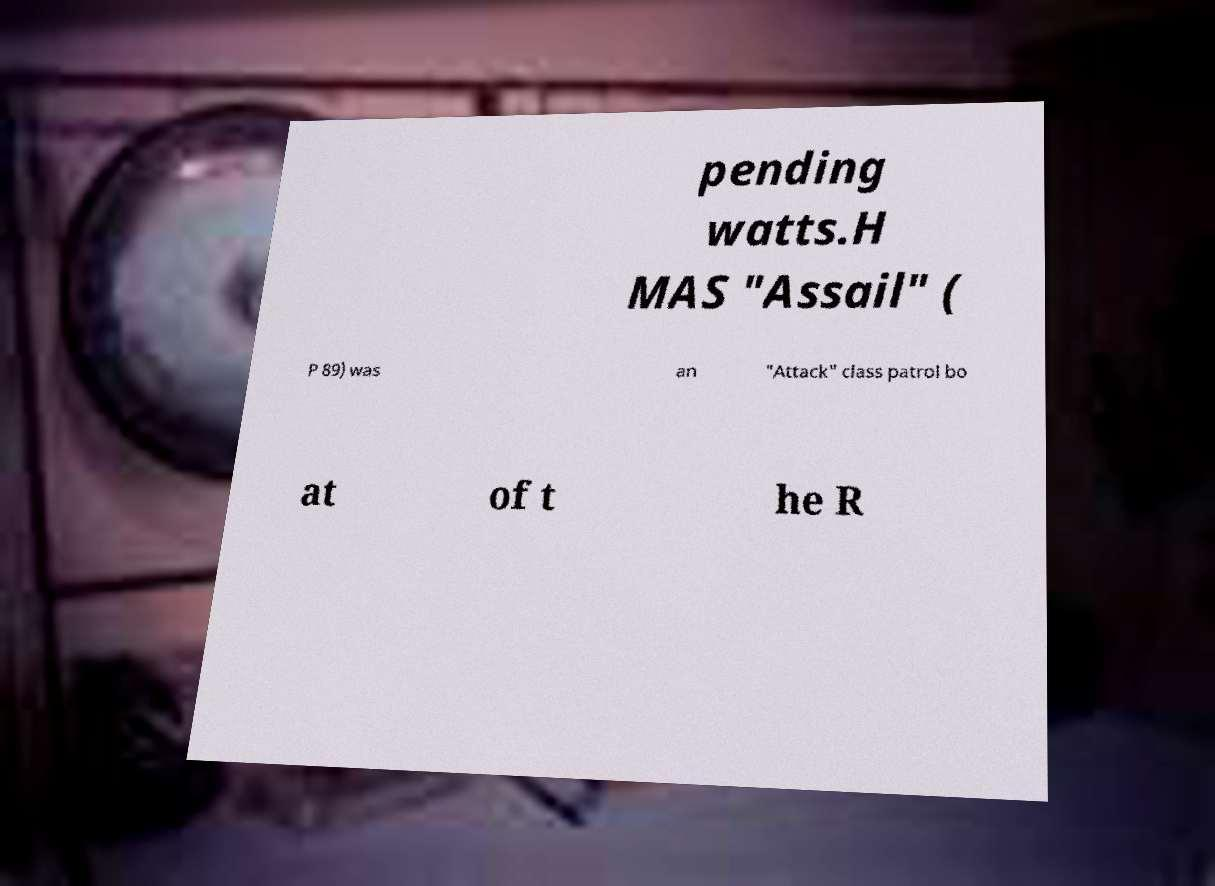For documentation purposes, I need the text within this image transcribed. Could you provide that? pending watts.H MAS "Assail" ( P 89) was an "Attack" class patrol bo at of t he R 